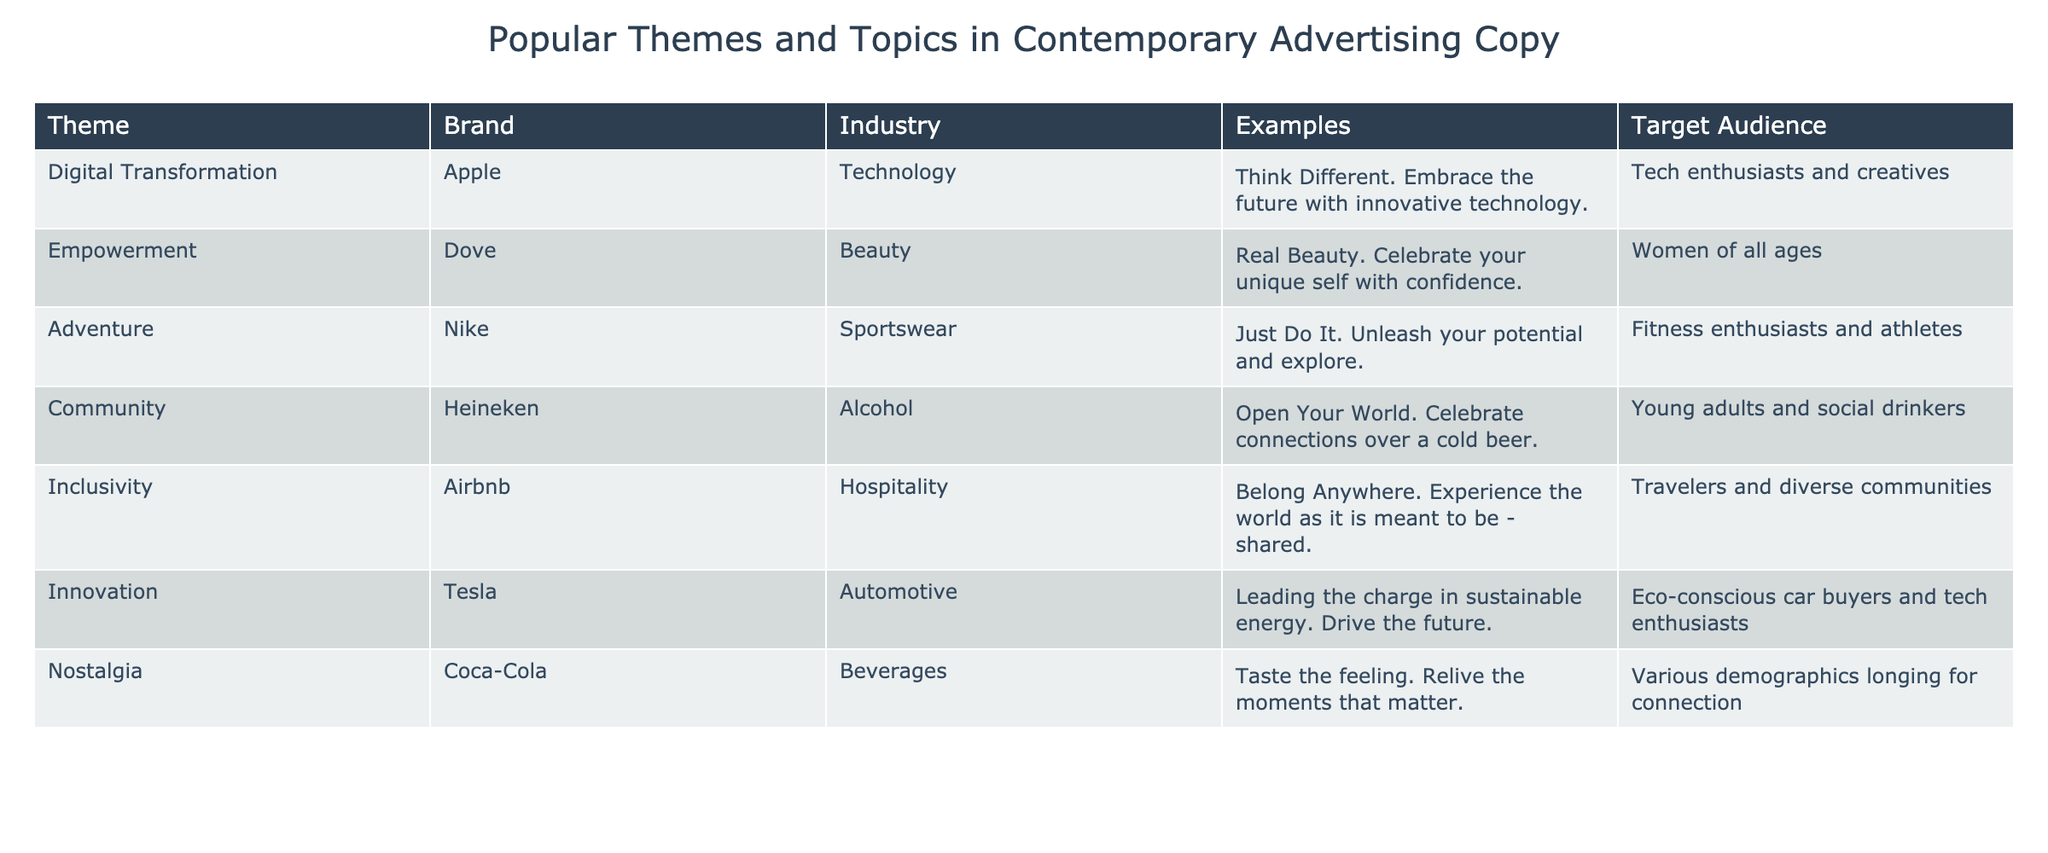What is the theme associated with Apple? From the table, Apple is linked to the theme of "Digital Transformation." This information is found in the first row of the table.
Answer: Digital Transformation Which brand uses the theme of empowerment? The table indicates that Dove employs the theme of "Empowerment," as noted in the second row.
Answer: Dove How many themes in the table focus on community and inclusivity? According to the table, there are two separate themes focusing on either community or inclusivity: "Community" (Heineken) and "Inclusivity" (Airbnb). Thus, we have a total of two.
Answer: 2 Is nostalgia a theme used by Coca-Cola? The table clearly states that Coca-Cola uses "Nostalgia" as its theme. Therefore, the answer to whether this statement is true is yes.
Answer: Yes Which industry has a theme of innovation, and what is the brand associated with it? The table reveals that the theme of "Innovation" is associated with the brand Tesla, which falls under the industry of "Automotive." This information is gathered from the sixth row of the table.
Answer: Automotive; Tesla What is the average target audience age group for the brands listed in the table? The table lists experiences for a diverse set of audiences, with target groups ranging from "young adults" to "women of all ages." However, we notice that the target audiences do not present numerical values, preventing us from calculating an average age group in numerical terms. Therefore, there is no average to provide.
Answer: Not applicable Which two brands are focused on themes that promote personal improvement and exploration? The table shows that Nike emphasizes the theme of "Adventure," encouraging exploration and personal growth, while Dove stresses "Empowerment," which is about personal confidence. Both brands target the self-improvement facet, reinforcing individual values.
Answer: Nike and Dove Does any brand in the table promote a theme related to technology? The table shows that Apple is linked with "Digital Transformation," which is related to technology. Thus, the answer to this question based on the data presented is true.
Answer: Yes How can the themes in the table be categorized by their underlying messages (e.g., personal, social, or environmental)? By analyzing the table, we can categorize the themes as follows: "Digital Transformation" (personal/technological), "Empowerment" (personal), "Adventure" (personal), "Community" (social), "Inclusivity" (social), "Innovation" (environmental), and "Nostalgia" (personal/sentimental). Therefore, we can identify several themes directed at personal improvement, and three themes aimed at social or communal connections.
Answer: Multiple categories identified 